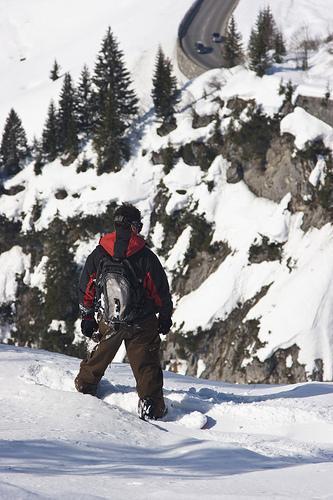How many people are there?
Give a very brief answer. 1. 